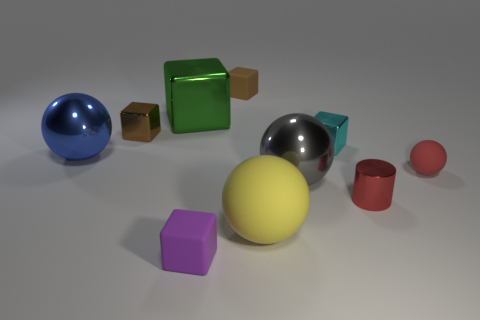Subtract all brown metallic cubes. How many cubes are left? 4 Subtract all green blocks. How many blocks are left? 4 Subtract all cyan balls. Subtract all green cylinders. How many balls are left? 4 Subtract all balls. How many objects are left? 6 Subtract all brown metal things. Subtract all green objects. How many objects are left? 8 Add 1 red matte balls. How many red matte balls are left? 2 Add 1 large cylinders. How many large cylinders exist? 1 Subtract 1 purple cubes. How many objects are left? 9 